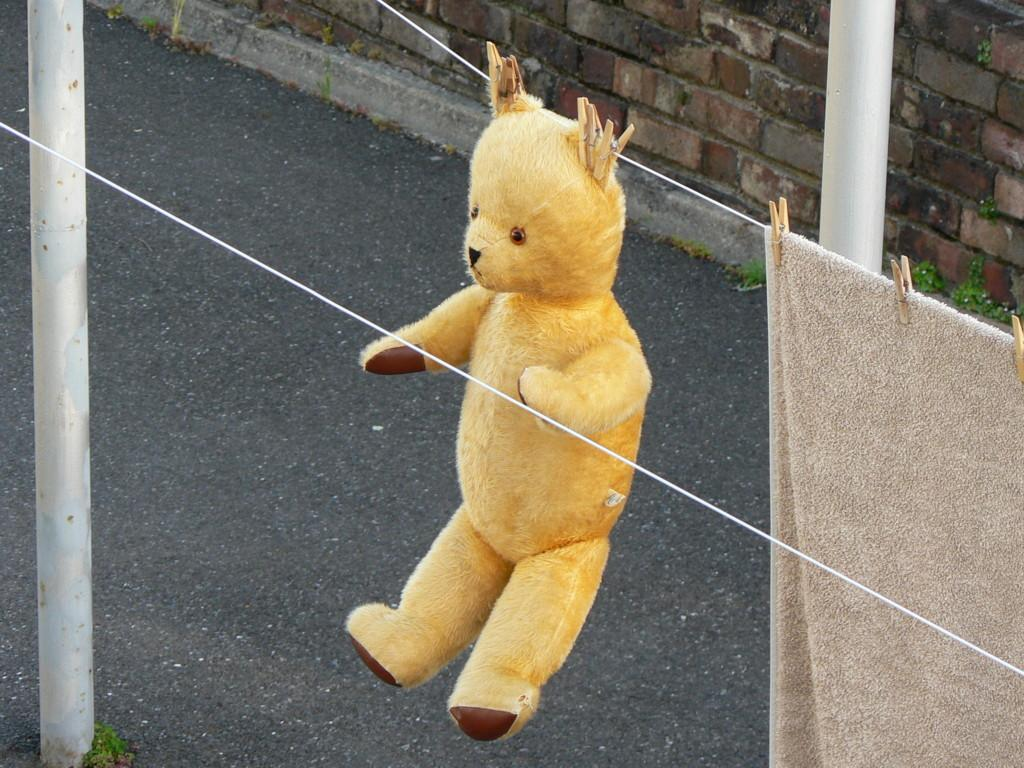What type of stuffed animal can be seen in the image? There is a teddy bear in the image. What is hanging on a rope in the image? There is a towel hanging on a rope in the image. What type of path is visible in the image? There is a road in the image. What type of vertical structures are present in the image? There are poles in the image. What can be seen in the background of the image? There is a wall visible in the background of the image. What type of clam is sitting on the wall in the image? There is no clam present in the image; it features a teddy bear, a towel, a road, poles, and a wall. What is the name of the person who owns the teddy bear in the image? There is no information about the owner of the teddy bear in the image, so we cannot determine their name. 